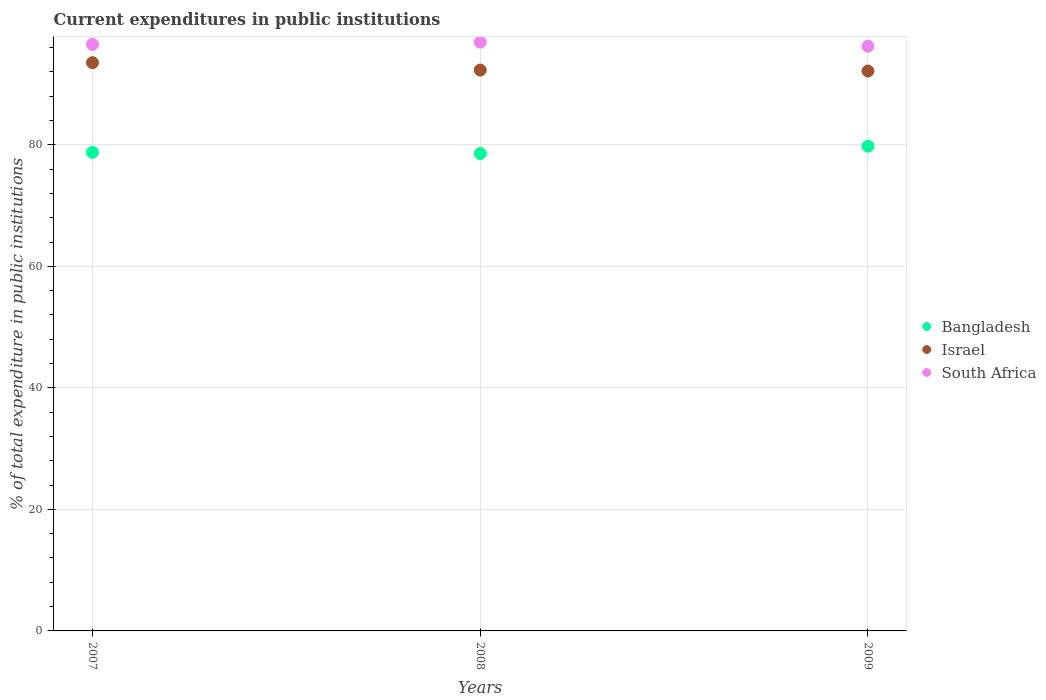Is the number of dotlines equal to the number of legend labels?
Keep it short and to the point. Yes. What is the current expenditures in public institutions in Bangladesh in 2008?
Make the answer very short. 78.56. Across all years, what is the maximum current expenditures in public institutions in Israel?
Offer a very short reply. 93.51. Across all years, what is the minimum current expenditures in public institutions in South Africa?
Offer a terse response. 96.22. What is the total current expenditures in public institutions in South Africa in the graph?
Your answer should be very brief. 289.63. What is the difference between the current expenditures in public institutions in Bangladesh in 2007 and that in 2008?
Provide a succinct answer. 0.19. What is the difference between the current expenditures in public institutions in Bangladesh in 2009 and the current expenditures in public institutions in Israel in 2008?
Your answer should be compact. -12.52. What is the average current expenditures in public institutions in Israel per year?
Offer a terse response. 92.64. In the year 2009, what is the difference between the current expenditures in public institutions in Israel and current expenditures in public institutions in South Africa?
Your response must be concise. -4.08. In how many years, is the current expenditures in public institutions in Bangladesh greater than 56 %?
Your answer should be very brief. 3. What is the ratio of the current expenditures in public institutions in Bangladesh in 2007 to that in 2009?
Your answer should be compact. 0.99. Is the current expenditures in public institutions in Israel in 2007 less than that in 2008?
Make the answer very short. No. Is the difference between the current expenditures in public institutions in Israel in 2008 and 2009 greater than the difference between the current expenditures in public institutions in South Africa in 2008 and 2009?
Your response must be concise. No. What is the difference between the highest and the second highest current expenditures in public institutions in Israel?
Keep it short and to the point. 1.22. What is the difference between the highest and the lowest current expenditures in public institutions in Bangladesh?
Offer a terse response. 1.21. In how many years, is the current expenditures in public institutions in Bangladesh greater than the average current expenditures in public institutions in Bangladesh taken over all years?
Make the answer very short. 1. Is the sum of the current expenditures in public institutions in South Africa in 2008 and 2009 greater than the maximum current expenditures in public institutions in Bangladesh across all years?
Give a very brief answer. Yes. Is it the case that in every year, the sum of the current expenditures in public institutions in Israel and current expenditures in public institutions in South Africa  is greater than the current expenditures in public institutions in Bangladesh?
Make the answer very short. Yes. Does the current expenditures in public institutions in South Africa monotonically increase over the years?
Make the answer very short. No. How many dotlines are there?
Give a very brief answer. 3. How many years are there in the graph?
Your answer should be very brief. 3. What is the difference between two consecutive major ticks on the Y-axis?
Provide a succinct answer. 20. Are the values on the major ticks of Y-axis written in scientific E-notation?
Keep it short and to the point. No. Does the graph contain any zero values?
Offer a very short reply. No. Does the graph contain grids?
Ensure brevity in your answer.  Yes. How are the legend labels stacked?
Make the answer very short. Vertical. What is the title of the graph?
Provide a succinct answer. Current expenditures in public institutions. Does "Latin America(developing only)" appear as one of the legend labels in the graph?
Keep it short and to the point. No. What is the label or title of the X-axis?
Ensure brevity in your answer.  Years. What is the label or title of the Y-axis?
Keep it short and to the point. % of total expenditure in public institutions. What is the % of total expenditure in public institutions in Bangladesh in 2007?
Provide a short and direct response. 78.76. What is the % of total expenditure in public institutions of Israel in 2007?
Your answer should be very brief. 93.51. What is the % of total expenditure in public institutions of South Africa in 2007?
Offer a very short reply. 96.53. What is the % of total expenditure in public institutions in Bangladesh in 2008?
Your answer should be compact. 78.56. What is the % of total expenditure in public institutions of Israel in 2008?
Ensure brevity in your answer.  92.29. What is the % of total expenditure in public institutions of South Africa in 2008?
Make the answer very short. 96.89. What is the % of total expenditure in public institutions in Bangladesh in 2009?
Offer a very short reply. 79.77. What is the % of total expenditure in public institutions in Israel in 2009?
Your answer should be very brief. 92.13. What is the % of total expenditure in public institutions of South Africa in 2009?
Provide a succinct answer. 96.22. Across all years, what is the maximum % of total expenditure in public institutions of Bangladesh?
Your answer should be very brief. 79.77. Across all years, what is the maximum % of total expenditure in public institutions in Israel?
Provide a succinct answer. 93.51. Across all years, what is the maximum % of total expenditure in public institutions in South Africa?
Give a very brief answer. 96.89. Across all years, what is the minimum % of total expenditure in public institutions of Bangladesh?
Offer a very short reply. 78.56. Across all years, what is the minimum % of total expenditure in public institutions of Israel?
Offer a terse response. 92.13. Across all years, what is the minimum % of total expenditure in public institutions in South Africa?
Provide a short and direct response. 96.22. What is the total % of total expenditure in public institutions in Bangladesh in the graph?
Your answer should be compact. 237.09. What is the total % of total expenditure in public institutions in Israel in the graph?
Give a very brief answer. 277.93. What is the total % of total expenditure in public institutions of South Africa in the graph?
Your answer should be compact. 289.63. What is the difference between the % of total expenditure in public institutions in Bangladesh in 2007 and that in 2008?
Provide a succinct answer. 0.19. What is the difference between the % of total expenditure in public institutions in Israel in 2007 and that in 2008?
Ensure brevity in your answer.  1.22. What is the difference between the % of total expenditure in public institutions in South Africa in 2007 and that in 2008?
Give a very brief answer. -0.36. What is the difference between the % of total expenditure in public institutions of Bangladesh in 2007 and that in 2009?
Provide a short and direct response. -1.01. What is the difference between the % of total expenditure in public institutions in Israel in 2007 and that in 2009?
Your response must be concise. 1.37. What is the difference between the % of total expenditure in public institutions in South Africa in 2007 and that in 2009?
Your response must be concise. 0.31. What is the difference between the % of total expenditure in public institutions in Bangladesh in 2008 and that in 2009?
Keep it short and to the point. -1.21. What is the difference between the % of total expenditure in public institutions of Israel in 2008 and that in 2009?
Offer a very short reply. 0.16. What is the difference between the % of total expenditure in public institutions of South Africa in 2008 and that in 2009?
Offer a very short reply. 0.67. What is the difference between the % of total expenditure in public institutions of Bangladesh in 2007 and the % of total expenditure in public institutions of Israel in 2008?
Offer a terse response. -13.53. What is the difference between the % of total expenditure in public institutions in Bangladesh in 2007 and the % of total expenditure in public institutions in South Africa in 2008?
Offer a very short reply. -18.13. What is the difference between the % of total expenditure in public institutions in Israel in 2007 and the % of total expenditure in public institutions in South Africa in 2008?
Ensure brevity in your answer.  -3.38. What is the difference between the % of total expenditure in public institutions in Bangladesh in 2007 and the % of total expenditure in public institutions in Israel in 2009?
Provide a succinct answer. -13.38. What is the difference between the % of total expenditure in public institutions of Bangladesh in 2007 and the % of total expenditure in public institutions of South Africa in 2009?
Keep it short and to the point. -17.46. What is the difference between the % of total expenditure in public institutions in Israel in 2007 and the % of total expenditure in public institutions in South Africa in 2009?
Give a very brief answer. -2.71. What is the difference between the % of total expenditure in public institutions in Bangladesh in 2008 and the % of total expenditure in public institutions in Israel in 2009?
Provide a short and direct response. -13.57. What is the difference between the % of total expenditure in public institutions of Bangladesh in 2008 and the % of total expenditure in public institutions of South Africa in 2009?
Make the answer very short. -17.65. What is the difference between the % of total expenditure in public institutions of Israel in 2008 and the % of total expenditure in public institutions of South Africa in 2009?
Offer a very short reply. -3.93. What is the average % of total expenditure in public institutions of Bangladesh per year?
Give a very brief answer. 79.03. What is the average % of total expenditure in public institutions of Israel per year?
Your response must be concise. 92.64. What is the average % of total expenditure in public institutions of South Africa per year?
Your answer should be very brief. 96.54. In the year 2007, what is the difference between the % of total expenditure in public institutions in Bangladesh and % of total expenditure in public institutions in Israel?
Your response must be concise. -14.75. In the year 2007, what is the difference between the % of total expenditure in public institutions in Bangladesh and % of total expenditure in public institutions in South Africa?
Offer a very short reply. -17.77. In the year 2007, what is the difference between the % of total expenditure in public institutions in Israel and % of total expenditure in public institutions in South Africa?
Your answer should be very brief. -3.02. In the year 2008, what is the difference between the % of total expenditure in public institutions of Bangladesh and % of total expenditure in public institutions of Israel?
Offer a terse response. -13.73. In the year 2008, what is the difference between the % of total expenditure in public institutions of Bangladesh and % of total expenditure in public institutions of South Africa?
Keep it short and to the point. -18.32. In the year 2008, what is the difference between the % of total expenditure in public institutions in Israel and % of total expenditure in public institutions in South Africa?
Ensure brevity in your answer.  -4.6. In the year 2009, what is the difference between the % of total expenditure in public institutions in Bangladesh and % of total expenditure in public institutions in Israel?
Provide a succinct answer. -12.36. In the year 2009, what is the difference between the % of total expenditure in public institutions in Bangladesh and % of total expenditure in public institutions in South Africa?
Your response must be concise. -16.45. In the year 2009, what is the difference between the % of total expenditure in public institutions of Israel and % of total expenditure in public institutions of South Africa?
Provide a short and direct response. -4.08. What is the ratio of the % of total expenditure in public institutions of Bangladesh in 2007 to that in 2008?
Your answer should be very brief. 1. What is the ratio of the % of total expenditure in public institutions in Israel in 2007 to that in 2008?
Keep it short and to the point. 1.01. What is the ratio of the % of total expenditure in public institutions in Bangladesh in 2007 to that in 2009?
Give a very brief answer. 0.99. What is the ratio of the % of total expenditure in public institutions in Israel in 2007 to that in 2009?
Provide a succinct answer. 1.01. What is the ratio of the % of total expenditure in public institutions in South Africa in 2007 to that in 2009?
Make the answer very short. 1. What is the ratio of the % of total expenditure in public institutions of Bangladesh in 2008 to that in 2009?
Keep it short and to the point. 0.98. What is the difference between the highest and the second highest % of total expenditure in public institutions of Bangladesh?
Offer a terse response. 1.01. What is the difference between the highest and the second highest % of total expenditure in public institutions in Israel?
Provide a short and direct response. 1.22. What is the difference between the highest and the second highest % of total expenditure in public institutions of South Africa?
Make the answer very short. 0.36. What is the difference between the highest and the lowest % of total expenditure in public institutions in Bangladesh?
Offer a terse response. 1.21. What is the difference between the highest and the lowest % of total expenditure in public institutions of Israel?
Offer a very short reply. 1.37. What is the difference between the highest and the lowest % of total expenditure in public institutions in South Africa?
Make the answer very short. 0.67. 